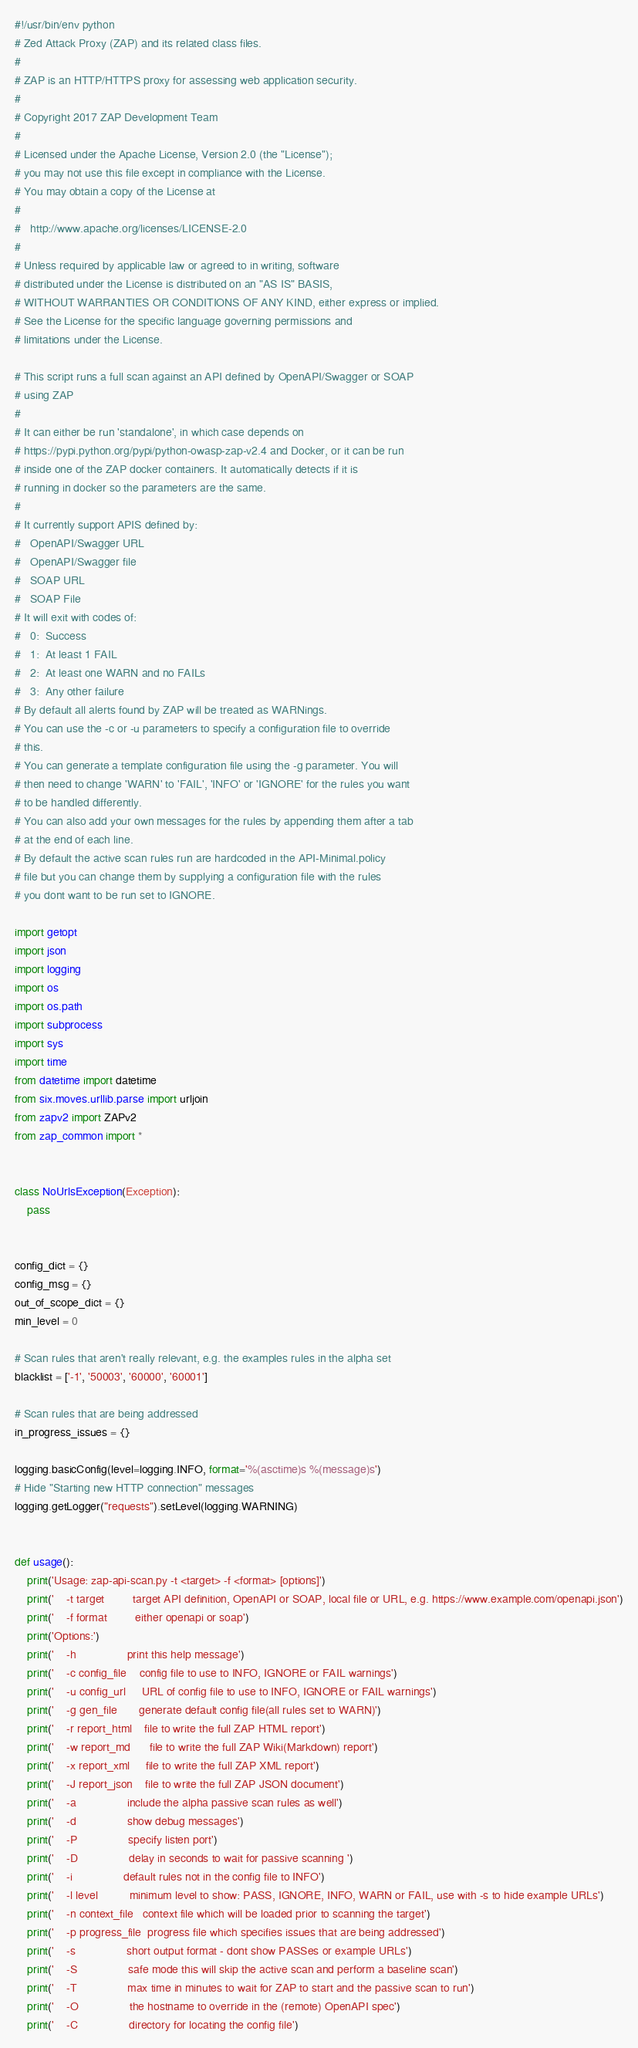<code> <loc_0><loc_0><loc_500><loc_500><_Python_>#!/usr/bin/env python
# Zed Attack Proxy (ZAP) and its related class files.
#
# ZAP is an HTTP/HTTPS proxy for assessing web application security.
#
# Copyright 2017 ZAP Development Team
#
# Licensed under the Apache License, Version 2.0 (the "License");
# you may not use this file except in compliance with the License.
# You may obtain a copy of the License at
#
#   http://www.apache.org/licenses/LICENSE-2.0
#
# Unless required by applicable law or agreed to in writing, software
# distributed under the License is distributed on an "AS IS" BASIS,
# WITHOUT WARRANTIES OR CONDITIONS OF ANY KIND, either express or implied.
# See the License for the specific language governing permissions and
# limitations under the License.

# This script runs a full scan against an API defined by OpenAPI/Swagger or SOAP
# using ZAP
#
# It can either be run 'standalone', in which case depends on
# https://pypi.python.org/pypi/python-owasp-zap-v2.4 and Docker, or it can be run
# inside one of the ZAP docker containers. It automatically detects if it is
# running in docker so the parameters are the same.
#
# It currently support APIS defined by:
#	OpenAPI/Swagger URL
#	OpenAPI/Swagger file
#	SOAP URL
#	SOAP File
# It will exit with codes of:
#	0:	Success
#	1:	At least 1 FAIL
#	2:	At least one WARN and no FAILs
#	3:	Any other failure
# By default all alerts found by ZAP will be treated as WARNings.
# You can use the -c or -u parameters to specify a configuration file to override
# this.
# You can generate a template configuration file using the -g parameter. You will
# then need to change 'WARN' to 'FAIL', 'INFO' or 'IGNORE' for the rules you want
# to be handled differently.
# You can also add your own messages for the rules by appending them after a tab
# at the end of each line.
# By default the active scan rules run are hardcoded in the API-Minimal.policy
# file but you can change them by supplying a configuration file with the rules
# you dont want to be run set to IGNORE.

import getopt
import json
import logging
import os
import os.path
import subprocess
import sys
import time
from datetime import datetime
from six.moves.urllib.parse import urljoin
from zapv2 import ZAPv2
from zap_common import *


class NoUrlsException(Exception):
    pass


config_dict = {}
config_msg = {}
out_of_scope_dict = {}
min_level = 0

# Scan rules that aren't really relevant, e.g. the examples rules in the alpha set
blacklist = ['-1', '50003', '60000', '60001']

# Scan rules that are being addressed
in_progress_issues = {}

logging.basicConfig(level=logging.INFO, format='%(asctime)s %(message)s')
# Hide "Starting new HTTP connection" messages
logging.getLogger("requests").setLevel(logging.WARNING)


def usage():
    print('Usage: zap-api-scan.py -t <target> -f <format> [options]')
    print('    -t target         target API definition, OpenAPI or SOAP, local file or URL, e.g. https://www.example.com/openapi.json')
    print('    -f format         either openapi or soap')
    print('Options:')
    print('    -h                print this help message')
    print('    -c config_file    config file to use to INFO, IGNORE or FAIL warnings')
    print('    -u config_url     URL of config file to use to INFO, IGNORE or FAIL warnings')
    print('    -g gen_file       generate default config file(all rules set to WARN)')
    print('    -r report_html    file to write the full ZAP HTML report')
    print('    -w report_md      file to write the full ZAP Wiki(Markdown) report')
    print('    -x report_xml     file to write the full ZAP XML report')
    print('    -J report_json    file to write the full ZAP JSON document')
    print('    -a                include the alpha passive scan rules as well')
    print('    -d                show debug messages')
    print('    -P                specify listen port')
    print('    -D                delay in seconds to wait for passive scanning ')
    print('    -i                default rules not in the config file to INFO')
    print('    -l level          minimum level to show: PASS, IGNORE, INFO, WARN or FAIL, use with -s to hide example URLs')
    print('    -n context_file   context file which will be loaded prior to scanning the target')
    print('    -p progress_file  progress file which specifies issues that are being addressed')
    print('    -s                short output format - dont show PASSes or example URLs')
    print('    -S                safe mode this will skip the active scan and perform a baseline scan')
    print('    -T                max time in minutes to wait for ZAP to start and the passive scan to run')
    print('    -O                the hostname to override in the (remote) OpenAPI spec')
    print('    -C                directory for locating the config file')</code> 